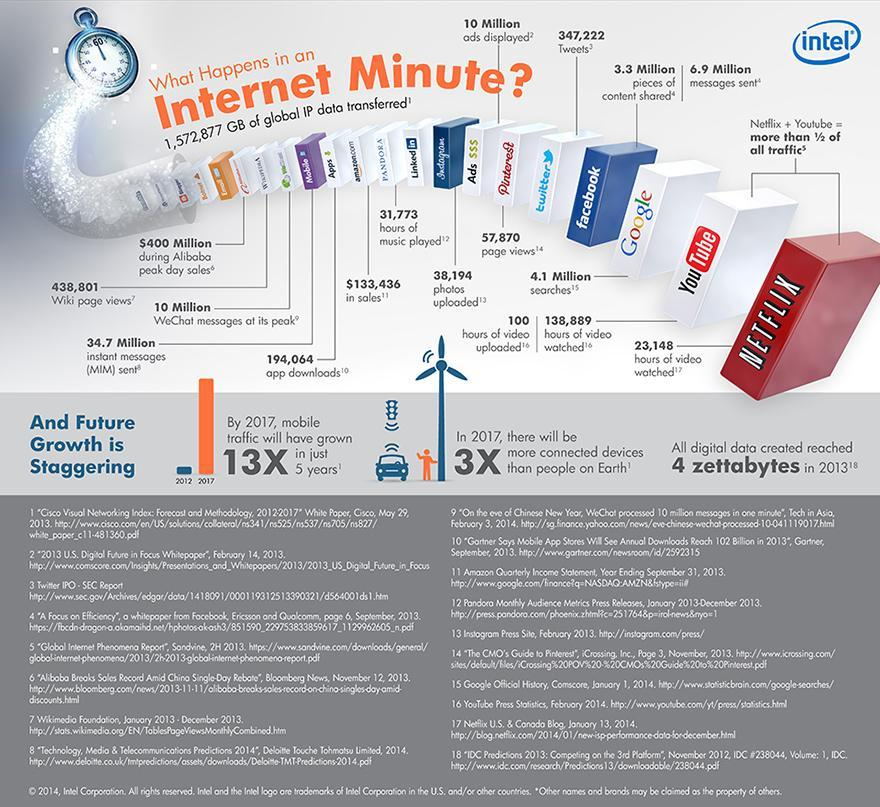What is the number of searches on google?
Answer the question with a short phrase. 4.1 Million What is the number of photos uploaded on Instagram? 38,194 What is the number of instant messages? 34.7 Million What is the number of app downloads? 194,064 